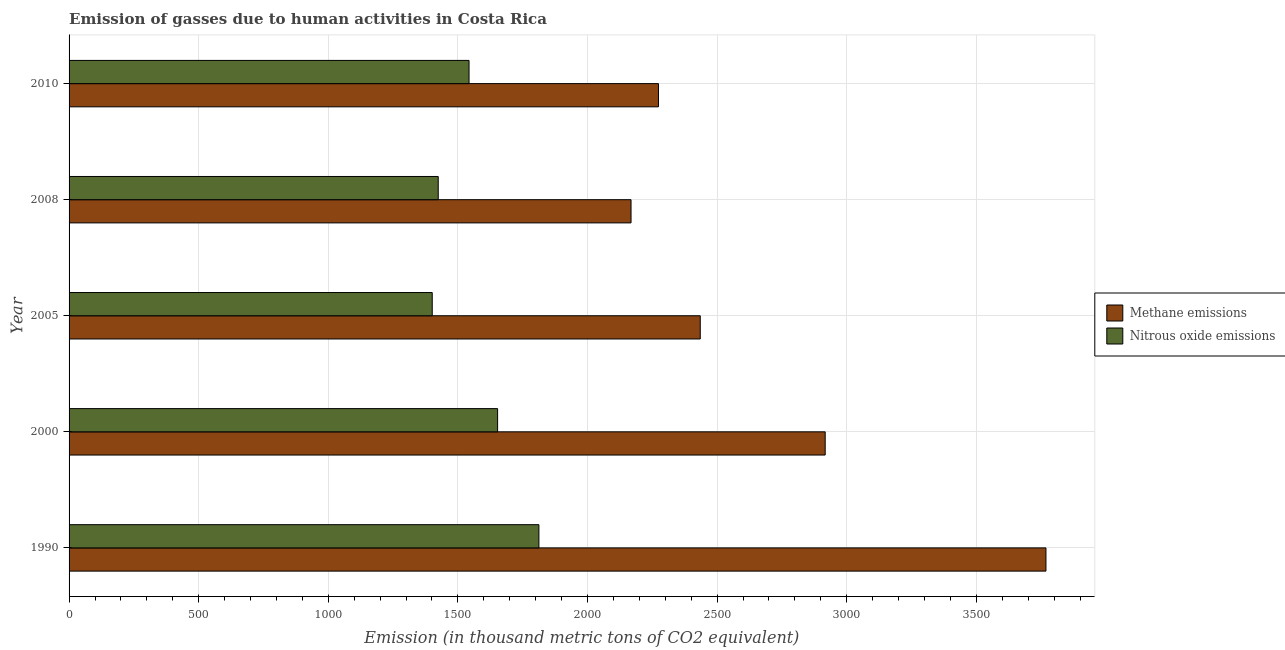Are the number of bars on each tick of the Y-axis equal?
Your answer should be compact. Yes. What is the amount of nitrous oxide emissions in 2010?
Your answer should be compact. 1543. Across all years, what is the maximum amount of methane emissions?
Your answer should be very brief. 3768.5. Across all years, what is the minimum amount of methane emissions?
Your response must be concise. 2167.9. In which year was the amount of methane emissions maximum?
Keep it short and to the point. 1990. What is the total amount of nitrous oxide emissions in the graph?
Keep it short and to the point. 7833.8. What is the difference between the amount of methane emissions in 2000 and that in 2005?
Your answer should be compact. 482. What is the difference between the amount of methane emissions in 2000 and the amount of nitrous oxide emissions in 2008?
Offer a terse response. 1492.8. What is the average amount of methane emissions per year?
Give a very brief answer. 2712.38. In the year 1990, what is the difference between the amount of methane emissions and amount of nitrous oxide emissions?
Provide a short and direct response. 1956. In how many years, is the amount of methane emissions greater than 2500 thousand metric tons?
Provide a short and direct response. 2. What is the ratio of the amount of nitrous oxide emissions in 2000 to that in 2008?
Offer a terse response. 1.16. What is the difference between the highest and the second highest amount of nitrous oxide emissions?
Keep it short and to the point. 159.3. What is the difference between the highest and the lowest amount of methane emissions?
Your answer should be very brief. 1600.6. What does the 2nd bar from the top in 2010 represents?
Offer a terse response. Methane emissions. What does the 2nd bar from the bottom in 2000 represents?
Make the answer very short. Nitrous oxide emissions. How many bars are there?
Your answer should be compact. 10. Are all the bars in the graph horizontal?
Provide a succinct answer. Yes. Are the values on the major ticks of X-axis written in scientific E-notation?
Provide a succinct answer. No. Where does the legend appear in the graph?
Offer a very short reply. Center right. What is the title of the graph?
Offer a very short reply. Emission of gasses due to human activities in Costa Rica. Does "Sanitation services" appear as one of the legend labels in the graph?
Give a very brief answer. No. What is the label or title of the X-axis?
Keep it short and to the point. Emission (in thousand metric tons of CO2 equivalent). What is the Emission (in thousand metric tons of CO2 equivalent) in Methane emissions in 1990?
Provide a succinct answer. 3768.5. What is the Emission (in thousand metric tons of CO2 equivalent) in Nitrous oxide emissions in 1990?
Your response must be concise. 1812.5. What is the Emission (in thousand metric tons of CO2 equivalent) of Methane emissions in 2000?
Your response must be concise. 2916.9. What is the Emission (in thousand metric tons of CO2 equivalent) of Nitrous oxide emissions in 2000?
Your answer should be compact. 1653.2. What is the Emission (in thousand metric tons of CO2 equivalent) of Methane emissions in 2005?
Keep it short and to the point. 2434.9. What is the Emission (in thousand metric tons of CO2 equivalent) of Nitrous oxide emissions in 2005?
Ensure brevity in your answer.  1401. What is the Emission (in thousand metric tons of CO2 equivalent) of Methane emissions in 2008?
Your answer should be compact. 2167.9. What is the Emission (in thousand metric tons of CO2 equivalent) of Nitrous oxide emissions in 2008?
Your response must be concise. 1424.1. What is the Emission (in thousand metric tons of CO2 equivalent) in Methane emissions in 2010?
Ensure brevity in your answer.  2273.7. What is the Emission (in thousand metric tons of CO2 equivalent) of Nitrous oxide emissions in 2010?
Offer a terse response. 1543. Across all years, what is the maximum Emission (in thousand metric tons of CO2 equivalent) in Methane emissions?
Ensure brevity in your answer.  3768.5. Across all years, what is the maximum Emission (in thousand metric tons of CO2 equivalent) in Nitrous oxide emissions?
Your answer should be very brief. 1812.5. Across all years, what is the minimum Emission (in thousand metric tons of CO2 equivalent) in Methane emissions?
Your response must be concise. 2167.9. Across all years, what is the minimum Emission (in thousand metric tons of CO2 equivalent) of Nitrous oxide emissions?
Keep it short and to the point. 1401. What is the total Emission (in thousand metric tons of CO2 equivalent) in Methane emissions in the graph?
Your answer should be compact. 1.36e+04. What is the total Emission (in thousand metric tons of CO2 equivalent) in Nitrous oxide emissions in the graph?
Give a very brief answer. 7833.8. What is the difference between the Emission (in thousand metric tons of CO2 equivalent) of Methane emissions in 1990 and that in 2000?
Provide a succinct answer. 851.6. What is the difference between the Emission (in thousand metric tons of CO2 equivalent) in Nitrous oxide emissions in 1990 and that in 2000?
Offer a very short reply. 159.3. What is the difference between the Emission (in thousand metric tons of CO2 equivalent) in Methane emissions in 1990 and that in 2005?
Make the answer very short. 1333.6. What is the difference between the Emission (in thousand metric tons of CO2 equivalent) in Nitrous oxide emissions in 1990 and that in 2005?
Give a very brief answer. 411.5. What is the difference between the Emission (in thousand metric tons of CO2 equivalent) in Methane emissions in 1990 and that in 2008?
Offer a terse response. 1600.6. What is the difference between the Emission (in thousand metric tons of CO2 equivalent) of Nitrous oxide emissions in 1990 and that in 2008?
Offer a very short reply. 388.4. What is the difference between the Emission (in thousand metric tons of CO2 equivalent) in Methane emissions in 1990 and that in 2010?
Provide a succinct answer. 1494.8. What is the difference between the Emission (in thousand metric tons of CO2 equivalent) of Nitrous oxide emissions in 1990 and that in 2010?
Your answer should be compact. 269.5. What is the difference between the Emission (in thousand metric tons of CO2 equivalent) of Methane emissions in 2000 and that in 2005?
Give a very brief answer. 482. What is the difference between the Emission (in thousand metric tons of CO2 equivalent) in Nitrous oxide emissions in 2000 and that in 2005?
Ensure brevity in your answer.  252.2. What is the difference between the Emission (in thousand metric tons of CO2 equivalent) of Methane emissions in 2000 and that in 2008?
Your answer should be very brief. 749. What is the difference between the Emission (in thousand metric tons of CO2 equivalent) in Nitrous oxide emissions in 2000 and that in 2008?
Make the answer very short. 229.1. What is the difference between the Emission (in thousand metric tons of CO2 equivalent) in Methane emissions in 2000 and that in 2010?
Provide a succinct answer. 643.2. What is the difference between the Emission (in thousand metric tons of CO2 equivalent) of Nitrous oxide emissions in 2000 and that in 2010?
Your answer should be very brief. 110.2. What is the difference between the Emission (in thousand metric tons of CO2 equivalent) of Methane emissions in 2005 and that in 2008?
Your response must be concise. 267. What is the difference between the Emission (in thousand metric tons of CO2 equivalent) of Nitrous oxide emissions in 2005 and that in 2008?
Offer a terse response. -23.1. What is the difference between the Emission (in thousand metric tons of CO2 equivalent) of Methane emissions in 2005 and that in 2010?
Your answer should be compact. 161.2. What is the difference between the Emission (in thousand metric tons of CO2 equivalent) of Nitrous oxide emissions in 2005 and that in 2010?
Ensure brevity in your answer.  -142. What is the difference between the Emission (in thousand metric tons of CO2 equivalent) of Methane emissions in 2008 and that in 2010?
Provide a short and direct response. -105.8. What is the difference between the Emission (in thousand metric tons of CO2 equivalent) in Nitrous oxide emissions in 2008 and that in 2010?
Give a very brief answer. -118.9. What is the difference between the Emission (in thousand metric tons of CO2 equivalent) in Methane emissions in 1990 and the Emission (in thousand metric tons of CO2 equivalent) in Nitrous oxide emissions in 2000?
Offer a very short reply. 2115.3. What is the difference between the Emission (in thousand metric tons of CO2 equivalent) of Methane emissions in 1990 and the Emission (in thousand metric tons of CO2 equivalent) of Nitrous oxide emissions in 2005?
Provide a succinct answer. 2367.5. What is the difference between the Emission (in thousand metric tons of CO2 equivalent) of Methane emissions in 1990 and the Emission (in thousand metric tons of CO2 equivalent) of Nitrous oxide emissions in 2008?
Provide a succinct answer. 2344.4. What is the difference between the Emission (in thousand metric tons of CO2 equivalent) of Methane emissions in 1990 and the Emission (in thousand metric tons of CO2 equivalent) of Nitrous oxide emissions in 2010?
Your answer should be very brief. 2225.5. What is the difference between the Emission (in thousand metric tons of CO2 equivalent) in Methane emissions in 2000 and the Emission (in thousand metric tons of CO2 equivalent) in Nitrous oxide emissions in 2005?
Ensure brevity in your answer.  1515.9. What is the difference between the Emission (in thousand metric tons of CO2 equivalent) of Methane emissions in 2000 and the Emission (in thousand metric tons of CO2 equivalent) of Nitrous oxide emissions in 2008?
Your answer should be compact. 1492.8. What is the difference between the Emission (in thousand metric tons of CO2 equivalent) in Methane emissions in 2000 and the Emission (in thousand metric tons of CO2 equivalent) in Nitrous oxide emissions in 2010?
Provide a short and direct response. 1373.9. What is the difference between the Emission (in thousand metric tons of CO2 equivalent) in Methane emissions in 2005 and the Emission (in thousand metric tons of CO2 equivalent) in Nitrous oxide emissions in 2008?
Offer a very short reply. 1010.8. What is the difference between the Emission (in thousand metric tons of CO2 equivalent) of Methane emissions in 2005 and the Emission (in thousand metric tons of CO2 equivalent) of Nitrous oxide emissions in 2010?
Ensure brevity in your answer.  891.9. What is the difference between the Emission (in thousand metric tons of CO2 equivalent) of Methane emissions in 2008 and the Emission (in thousand metric tons of CO2 equivalent) of Nitrous oxide emissions in 2010?
Provide a short and direct response. 624.9. What is the average Emission (in thousand metric tons of CO2 equivalent) in Methane emissions per year?
Offer a terse response. 2712.38. What is the average Emission (in thousand metric tons of CO2 equivalent) in Nitrous oxide emissions per year?
Make the answer very short. 1566.76. In the year 1990, what is the difference between the Emission (in thousand metric tons of CO2 equivalent) in Methane emissions and Emission (in thousand metric tons of CO2 equivalent) in Nitrous oxide emissions?
Provide a succinct answer. 1956. In the year 2000, what is the difference between the Emission (in thousand metric tons of CO2 equivalent) of Methane emissions and Emission (in thousand metric tons of CO2 equivalent) of Nitrous oxide emissions?
Make the answer very short. 1263.7. In the year 2005, what is the difference between the Emission (in thousand metric tons of CO2 equivalent) of Methane emissions and Emission (in thousand metric tons of CO2 equivalent) of Nitrous oxide emissions?
Your response must be concise. 1033.9. In the year 2008, what is the difference between the Emission (in thousand metric tons of CO2 equivalent) in Methane emissions and Emission (in thousand metric tons of CO2 equivalent) in Nitrous oxide emissions?
Your response must be concise. 743.8. In the year 2010, what is the difference between the Emission (in thousand metric tons of CO2 equivalent) in Methane emissions and Emission (in thousand metric tons of CO2 equivalent) in Nitrous oxide emissions?
Your answer should be very brief. 730.7. What is the ratio of the Emission (in thousand metric tons of CO2 equivalent) of Methane emissions in 1990 to that in 2000?
Provide a succinct answer. 1.29. What is the ratio of the Emission (in thousand metric tons of CO2 equivalent) of Nitrous oxide emissions in 1990 to that in 2000?
Your answer should be very brief. 1.1. What is the ratio of the Emission (in thousand metric tons of CO2 equivalent) of Methane emissions in 1990 to that in 2005?
Offer a very short reply. 1.55. What is the ratio of the Emission (in thousand metric tons of CO2 equivalent) of Nitrous oxide emissions in 1990 to that in 2005?
Provide a succinct answer. 1.29. What is the ratio of the Emission (in thousand metric tons of CO2 equivalent) in Methane emissions in 1990 to that in 2008?
Offer a terse response. 1.74. What is the ratio of the Emission (in thousand metric tons of CO2 equivalent) of Nitrous oxide emissions in 1990 to that in 2008?
Offer a terse response. 1.27. What is the ratio of the Emission (in thousand metric tons of CO2 equivalent) in Methane emissions in 1990 to that in 2010?
Make the answer very short. 1.66. What is the ratio of the Emission (in thousand metric tons of CO2 equivalent) of Nitrous oxide emissions in 1990 to that in 2010?
Your answer should be compact. 1.17. What is the ratio of the Emission (in thousand metric tons of CO2 equivalent) in Methane emissions in 2000 to that in 2005?
Keep it short and to the point. 1.2. What is the ratio of the Emission (in thousand metric tons of CO2 equivalent) of Nitrous oxide emissions in 2000 to that in 2005?
Offer a terse response. 1.18. What is the ratio of the Emission (in thousand metric tons of CO2 equivalent) of Methane emissions in 2000 to that in 2008?
Offer a terse response. 1.35. What is the ratio of the Emission (in thousand metric tons of CO2 equivalent) of Nitrous oxide emissions in 2000 to that in 2008?
Offer a terse response. 1.16. What is the ratio of the Emission (in thousand metric tons of CO2 equivalent) of Methane emissions in 2000 to that in 2010?
Your answer should be very brief. 1.28. What is the ratio of the Emission (in thousand metric tons of CO2 equivalent) of Nitrous oxide emissions in 2000 to that in 2010?
Your response must be concise. 1.07. What is the ratio of the Emission (in thousand metric tons of CO2 equivalent) of Methane emissions in 2005 to that in 2008?
Provide a succinct answer. 1.12. What is the ratio of the Emission (in thousand metric tons of CO2 equivalent) of Nitrous oxide emissions in 2005 to that in 2008?
Your response must be concise. 0.98. What is the ratio of the Emission (in thousand metric tons of CO2 equivalent) of Methane emissions in 2005 to that in 2010?
Your answer should be very brief. 1.07. What is the ratio of the Emission (in thousand metric tons of CO2 equivalent) of Nitrous oxide emissions in 2005 to that in 2010?
Offer a very short reply. 0.91. What is the ratio of the Emission (in thousand metric tons of CO2 equivalent) of Methane emissions in 2008 to that in 2010?
Make the answer very short. 0.95. What is the ratio of the Emission (in thousand metric tons of CO2 equivalent) in Nitrous oxide emissions in 2008 to that in 2010?
Provide a succinct answer. 0.92. What is the difference between the highest and the second highest Emission (in thousand metric tons of CO2 equivalent) in Methane emissions?
Provide a short and direct response. 851.6. What is the difference between the highest and the second highest Emission (in thousand metric tons of CO2 equivalent) of Nitrous oxide emissions?
Give a very brief answer. 159.3. What is the difference between the highest and the lowest Emission (in thousand metric tons of CO2 equivalent) of Methane emissions?
Give a very brief answer. 1600.6. What is the difference between the highest and the lowest Emission (in thousand metric tons of CO2 equivalent) of Nitrous oxide emissions?
Ensure brevity in your answer.  411.5. 